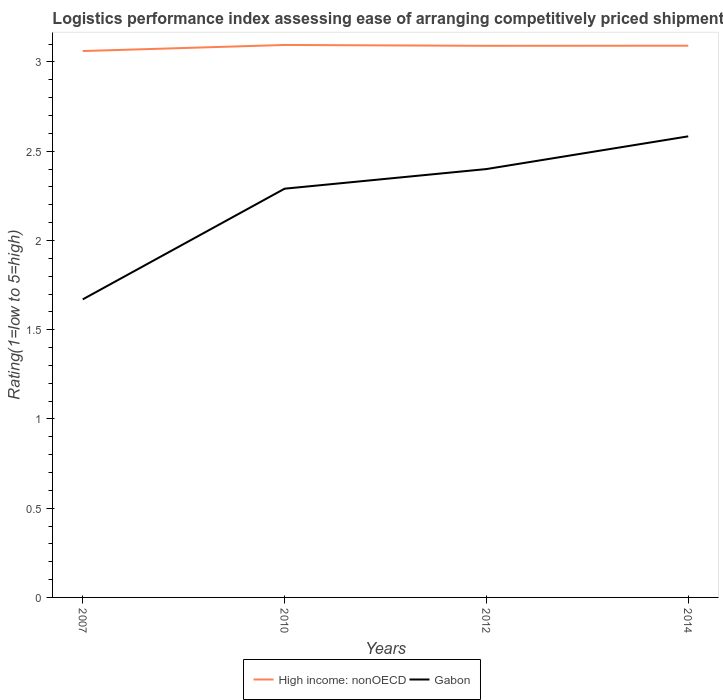How many different coloured lines are there?
Make the answer very short. 2. Does the line corresponding to Gabon intersect with the line corresponding to High income: nonOECD?
Your answer should be compact. No. Across all years, what is the maximum Logistic performance index in High income: nonOECD?
Offer a terse response. 3.06. What is the total Logistic performance index in Gabon in the graph?
Provide a succinct answer. -0.73. What is the difference between the highest and the second highest Logistic performance index in Gabon?
Provide a short and direct response. 0.91. How many lines are there?
Ensure brevity in your answer.  2. How many years are there in the graph?
Your response must be concise. 4. What is the difference between two consecutive major ticks on the Y-axis?
Keep it short and to the point. 0.5. Are the values on the major ticks of Y-axis written in scientific E-notation?
Provide a succinct answer. No. Does the graph contain grids?
Make the answer very short. No. Where does the legend appear in the graph?
Your response must be concise. Bottom center. How are the legend labels stacked?
Make the answer very short. Horizontal. What is the title of the graph?
Make the answer very short. Logistics performance index assessing ease of arranging competitively priced shipments to markets. Does "United Arab Emirates" appear as one of the legend labels in the graph?
Give a very brief answer. No. What is the label or title of the Y-axis?
Keep it short and to the point. Rating(1=low to 5=high). What is the Rating(1=low to 5=high) of High income: nonOECD in 2007?
Ensure brevity in your answer.  3.06. What is the Rating(1=low to 5=high) in Gabon in 2007?
Make the answer very short. 1.67. What is the Rating(1=low to 5=high) of High income: nonOECD in 2010?
Keep it short and to the point. 3.1. What is the Rating(1=low to 5=high) in Gabon in 2010?
Offer a terse response. 2.29. What is the Rating(1=low to 5=high) of High income: nonOECD in 2012?
Make the answer very short. 3.09. What is the Rating(1=low to 5=high) of Gabon in 2012?
Provide a short and direct response. 2.4. What is the Rating(1=low to 5=high) in High income: nonOECD in 2014?
Ensure brevity in your answer.  3.09. What is the Rating(1=low to 5=high) in Gabon in 2014?
Keep it short and to the point. 2.58. Across all years, what is the maximum Rating(1=low to 5=high) in High income: nonOECD?
Make the answer very short. 3.1. Across all years, what is the maximum Rating(1=low to 5=high) of Gabon?
Ensure brevity in your answer.  2.58. Across all years, what is the minimum Rating(1=low to 5=high) of High income: nonOECD?
Your answer should be very brief. 3.06. Across all years, what is the minimum Rating(1=low to 5=high) in Gabon?
Provide a short and direct response. 1.67. What is the total Rating(1=low to 5=high) in High income: nonOECD in the graph?
Provide a succinct answer. 12.34. What is the total Rating(1=low to 5=high) of Gabon in the graph?
Offer a very short reply. 8.94. What is the difference between the Rating(1=low to 5=high) of High income: nonOECD in 2007 and that in 2010?
Your response must be concise. -0.03. What is the difference between the Rating(1=low to 5=high) in Gabon in 2007 and that in 2010?
Ensure brevity in your answer.  -0.62. What is the difference between the Rating(1=low to 5=high) of High income: nonOECD in 2007 and that in 2012?
Give a very brief answer. -0.03. What is the difference between the Rating(1=low to 5=high) in Gabon in 2007 and that in 2012?
Make the answer very short. -0.73. What is the difference between the Rating(1=low to 5=high) of High income: nonOECD in 2007 and that in 2014?
Offer a terse response. -0.03. What is the difference between the Rating(1=low to 5=high) in Gabon in 2007 and that in 2014?
Your response must be concise. -0.91. What is the difference between the Rating(1=low to 5=high) of High income: nonOECD in 2010 and that in 2012?
Offer a very short reply. 0. What is the difference between the Rating(1=low to 5=high) of Gabon in 2010 and that in 2012?
Ensure brevity in your answer.  -0.11. What is the difference between the Rating(1=low to 5=high) in High income: nonOECD in 2010 and that in 2014?
Ensure brevity in your answer.  0. What is the difference between the Rating(1=low to 5=high) of Gabon in 2010 and that in 2014?
Make the answer very short. -0.29. What is the difference between the Rating(1=low to 5=high) in High income: nonOECD in 2012 and that in 2014?
Ensure brevity in your answer.  -0. What is the difference between the Rating(1=low to 5=high) of Gabon in 2012 and that in 2014?
Your answer should be very brief. -0.18. What is the difference between the Rating(1=low to 5=high) of High income: nonOECD in 2007 and the Rating(1=low to 5=high) of Gabon in 2010?
Your response must be concise. 0.77. What is the difference between the Rating(1=low to 5=high) in High income: nonOECD in 2007 and the Rating(1=low to 5=high) in Gabon in 2012?
Provide a short and direct response. 0.66. What is the difference between the Rating(1=low to 5=high) in High income: nonOECD in 2007 and the Rating(1=low to 5=high) in Gabon in 2014?
Provide a short and direct response. 0.48. What is the difference between the Rating(1=low to 5=high) of High income: nonOECD in 2010 and the Rating(1=low to 5=high) of Gabon in 2012?
Ensure brevity in your answer.  0.7. What is the difference between the Rating(1=low to 5=high) of High income: nonOECD in 2010 and the Rating(1=low to 5=high) of Gabon in 2014?
Provide a succinct answer. 0.51. What is the difference between the Rating(1=low to 5=high) of High income: nonOECD in 2012 and the Rating(1=low to 5=high) of Gabon in 2014?
Provide a succinct answer. 0.51. What is the average Rating(1=low to 5=high) of High income: nonOECD per year?
Your answer should be very brief. 3.08. What is the average Rating(1=low to 5=high) of Gabon per year?
Make the answer very short. 2.24. In the year 2007, what is the difference between the Rating(1=low to 5=high) in High income: nonOECD and Rating(1=low to 5=high) in Gabon?
Provide a succinct answer. 1.39. In the year 2010, what is the difference between the Rating(1=low to 5=high) of High income: nonOECD and Rating(1=low to 5=high) of Gabon?
Give a very brief answer. 0.81. In the year 2012, what is the difference between the Rating(1=low to 5=high) in High income: nonOECD and Rating(1=low to 5=high) in Gabon?
Keep it short and to the point. 0.69. In the year 2014, what is the difference between the Rating(1=low to 5=high) of High income: nonOECD and Rating(1=low to 5=high) of Gabon?
Ensure brevity in your answer.  0.51. What is the ratio of the Rating(1=low to 5=high) in Gabon in 2007 to that in 2010?
Offer a very short reply. 0.73. What is the ratio of the Rating(1=low to 5=high) of High income: nonOECD in 2007 to that in 2012?
Your answer should be very brief. 0.99. What is the ratio of the Rating(1=low to 5=high) in Gabon in 2007 to that in 2012?
Make the answer very short. 0.7. What is the ratio of the Rating(1=low to 5=high) of High income: nonOECD in 2007 to that in 2014?
Offer a terse response. 0.99. What is the ratio of the Rating(1=low to 5=high) of Gabon in 2007 to that in 2014?
Provide a succinct answer. 0.65. What is the ratio of the Rating(1=low to 5=high) of Gabon in 2010 to that in 2012?
Make the answer very short. 0.95. What is the ratio of the Rating(1=low to 5=high) in High income: nonOECD in 2010 to that in 2014?
Give a very brief answer. 1. What is the ratio of the Rating(1=low to 5=high) of Gabon in 2010 to that in 2014?
Your response must be concise. 0.89. What is the ratio of the Rating(1=low to 5=high) of High income: nonOECD in 2012 to that in 2014?
Your answer should be very brief. 1. What is the ratio of the Rating(1=low to 5=high) of Gabon in 2012 to that in 2014?
Ensure brevity in your answer.  0.93. What is the difference between the highest and the second highest Rating(1=low to 5=high) in High income: nonOECD?
Offer a very short reply. 0. What is the difference between the highest and the second highest Rating(1=low to 5=high) in Gabon?
Provide a succinct answer. 0.18. What is the difference between the highest and the lowest Rating(1=low to 5=high) in High income: nonOECD?
Make the answer very short. 0.03. What is the difference between the highest and the lowest Rating(1=low to 5=high) of Gabon?
Ensure brevity in your answer.  0.91. 